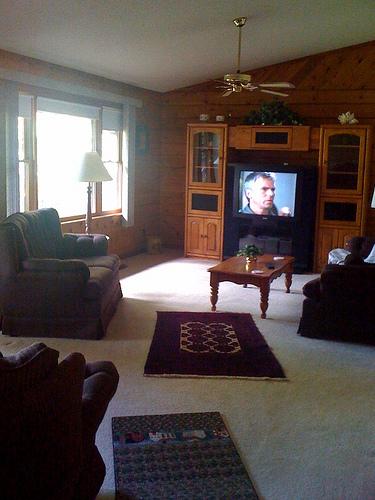Do they have a pet?
Answer briefly. No. Is the room clean?
Quick response, please. Yes. Is the TV off?
Quick response, please. No. Is someone sitting on the sofa?
Answer briefly. No. 